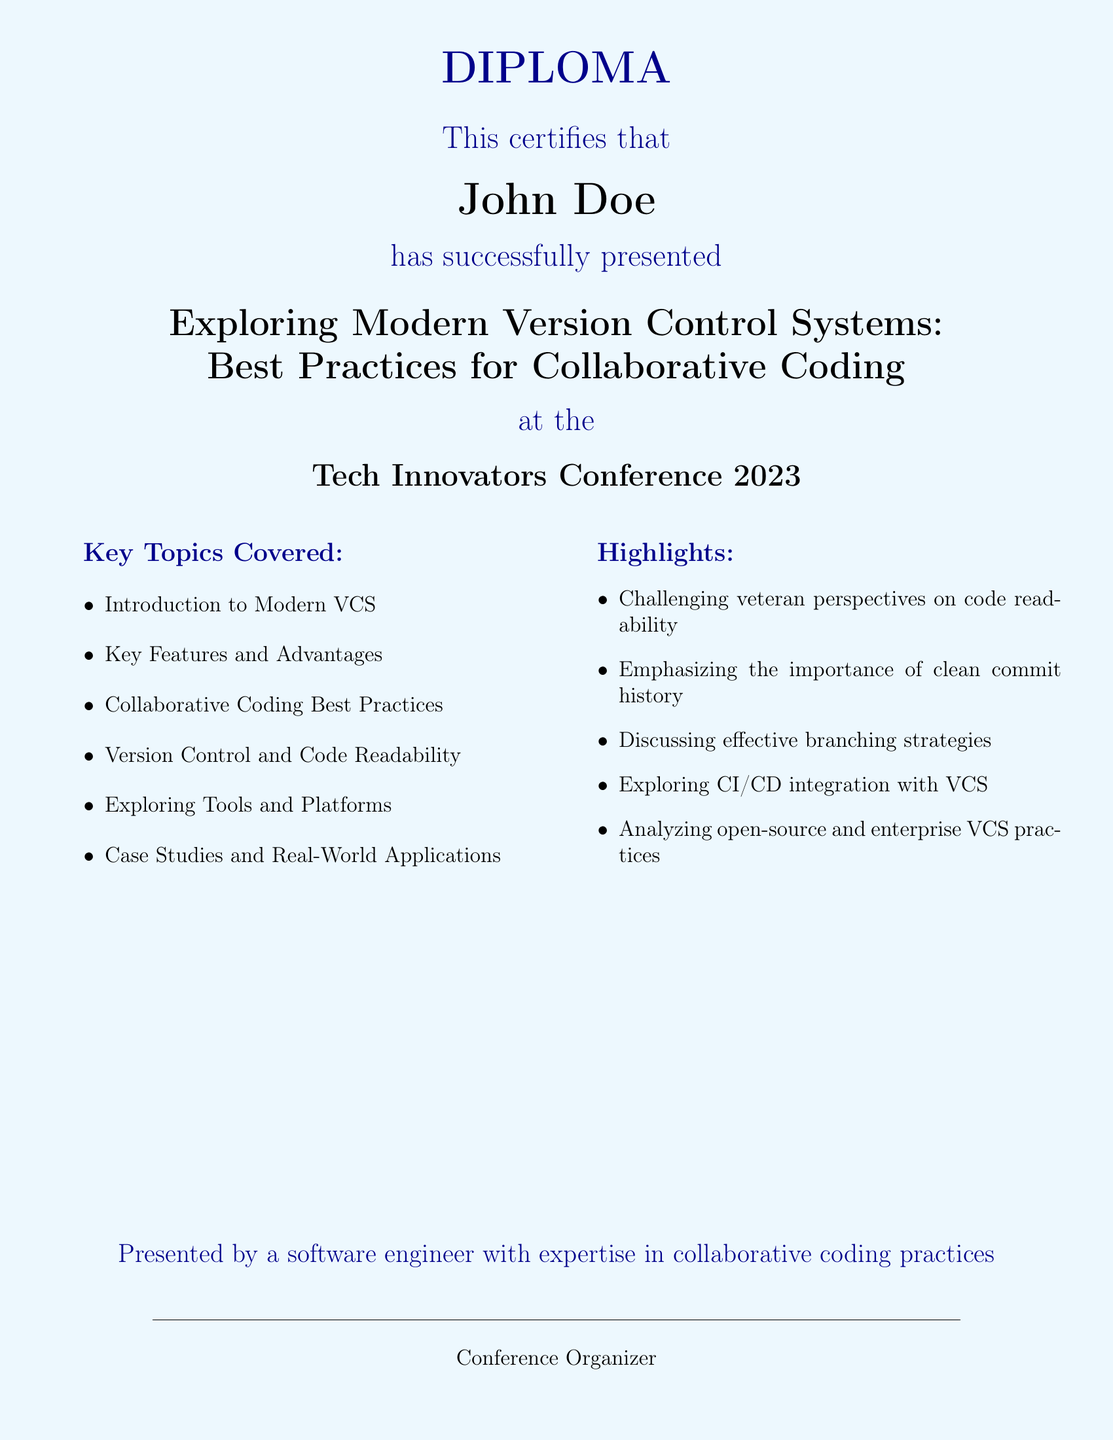What is the name of the recipient? The diploma certifies that John Doe is the recipient.
Answer: John Doe What is the title of the presentation? The title of the presentation is stated in the document as "Exploring Modern Version Control Systems: Best Practices for Collaborative Coding."
Answer: Exploring Modern Version Control Systems: Best Practices for Collaborative Coding What year was the Tech Innovators Conference held? The document mentions that the conference took place in 2023.
Answer: 2023 What color is used for the section titles? The document specifies that section titles use a dark blue color.
Answer: dark blue What is one key topic covered in the document? The document lists several topics, one of which is "Collaborative Coding Best Practices."
Answer: Collaborative Coding Best Practices Who presented the diploma? The diploma is presented by a software engineer with expertise in collaborative coding practices.
Answer: a software engineer with expertise in collaborative coding practices What was emphasized regarding commit history? The document highlights the importance of a clean commit history.
Answer: clean commit history Which area was analyzed in the highlights section? The highlights section mentions the analysis of open-source and enterprise VCS practices.
Answer: open-source and enterprise VCS practices 